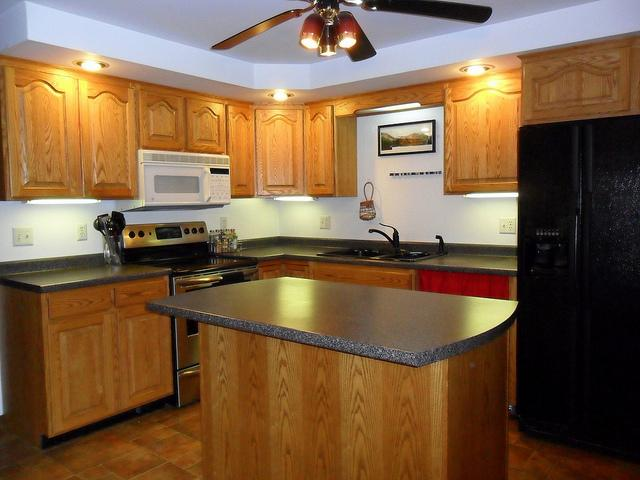What might a person make on the black and silver item on the back left?

Choices:
A) jewellery
B) clothing
C) food
D) music food 